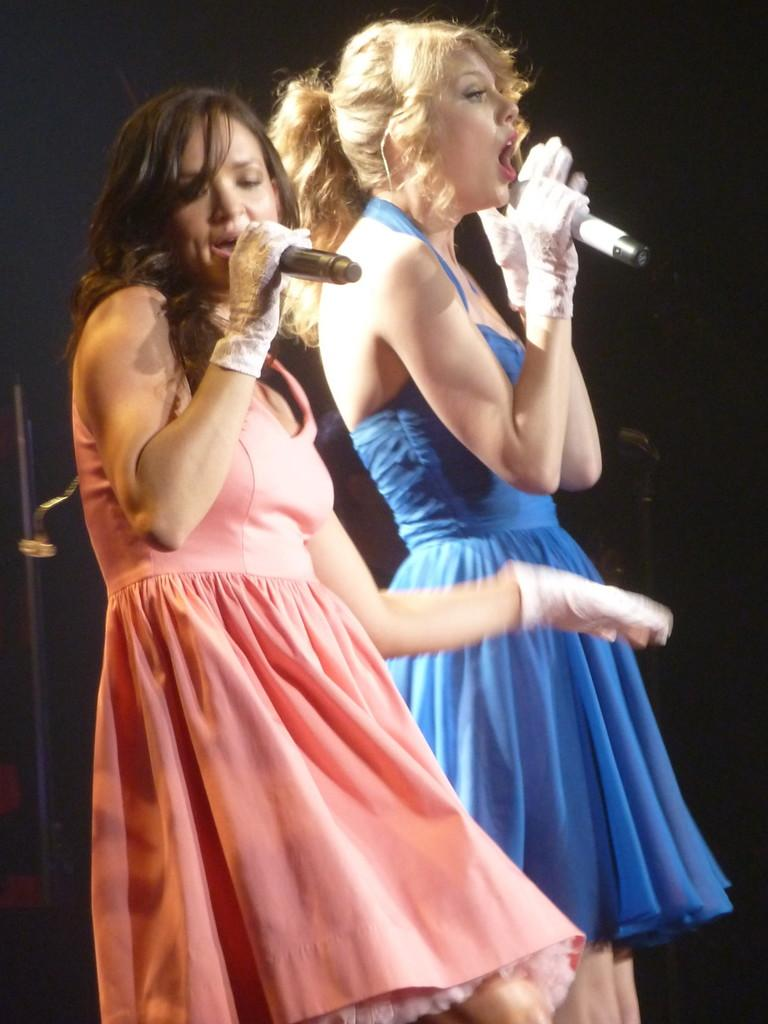How many people are in the image? There are two women in the image. What are the women doing in the image? The women are singing. What objects are the women holding in the image? The women are holding microphones. Can you see a worm crawling on the ground in the image? There is no worm visible in the image. What type of rest are the women taking in the image? The women are not resting in the image; they are singing and holding microphones. 